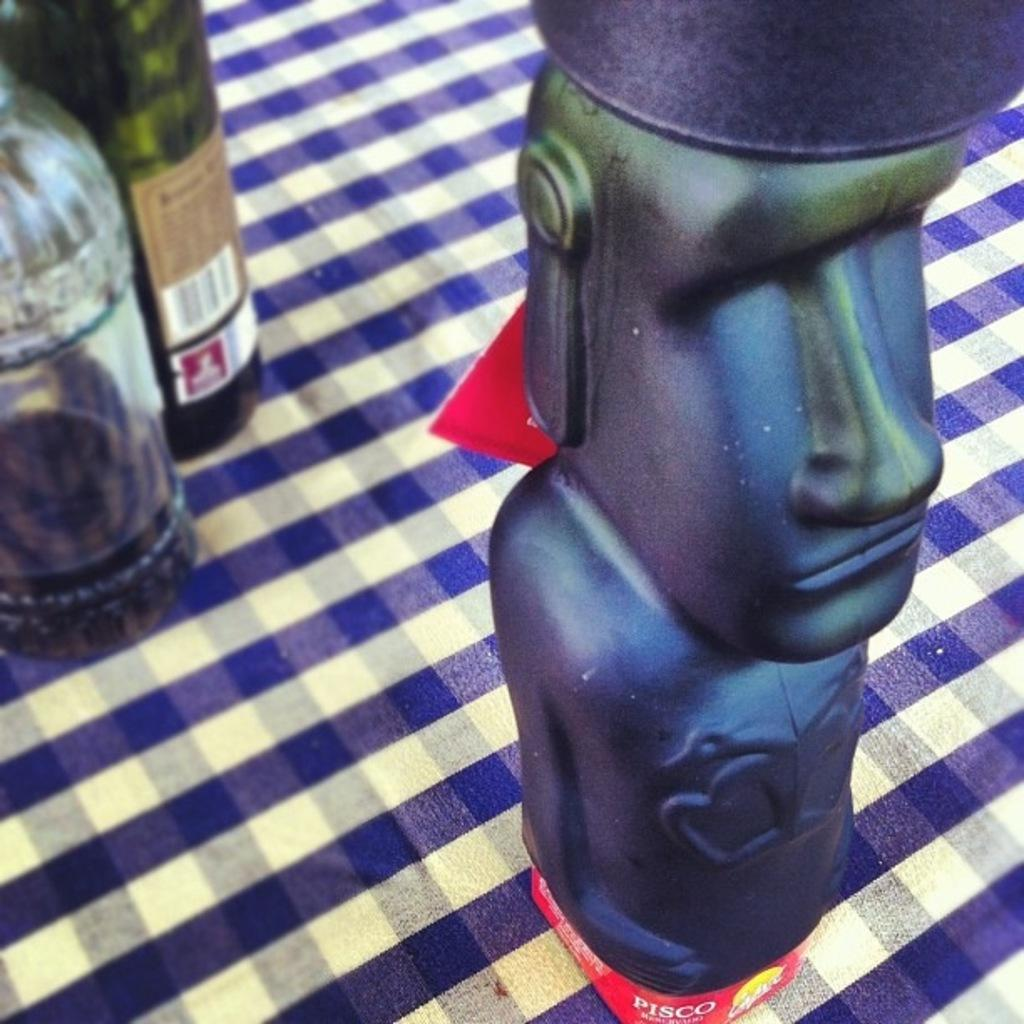What object can be seen in the image that is meant for play or entertainment? There is a toy in the image. Where is the toy located in the image? The toy is on a table. What other objects are on the table in the image? There are a couple of bottles on the table. What flavor of the bridge can be seen in the image? There is no bridge present in the image, so it is not possible to determine the flavor of a bridge. 